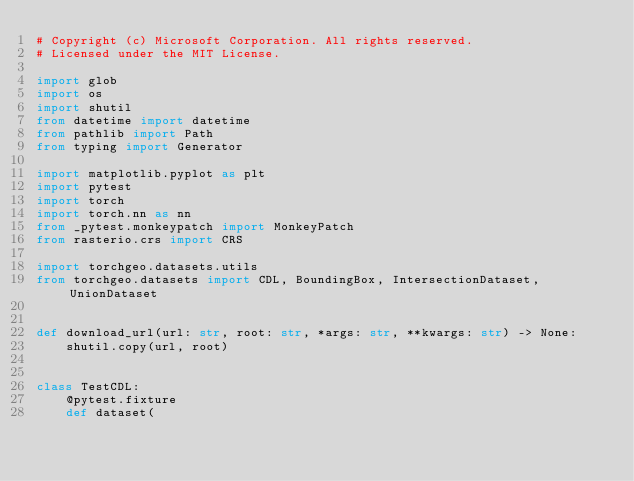<code> <loc_0><loc_0><loc_500><loc_500><_Python_># Copyright (c) Microsoft Corporation. All rights reserved.
# Licensed under the MIT License.

import glob
import os
import shutil
from datetime import datetime
from pathlib import Path
from typing import Generator

import matplotlib.pyplot as plt
import pytest
import torch
import torch.nn as nn
from _pytest.monkeypatch import MonkeyPatch
from rasterio.crs import CRS

import torchgeo.datasets.utils
from torchgeo.datasets import CDL, BoundingBox, IntersectionDataset, UnionDataset


def download_url(url: str, root: str, *args: str, **kwargs: str) -> None:
    shutil.copy(url, root)


class TestCDL:
    @pytest.fixture
    def dataset(</code> 